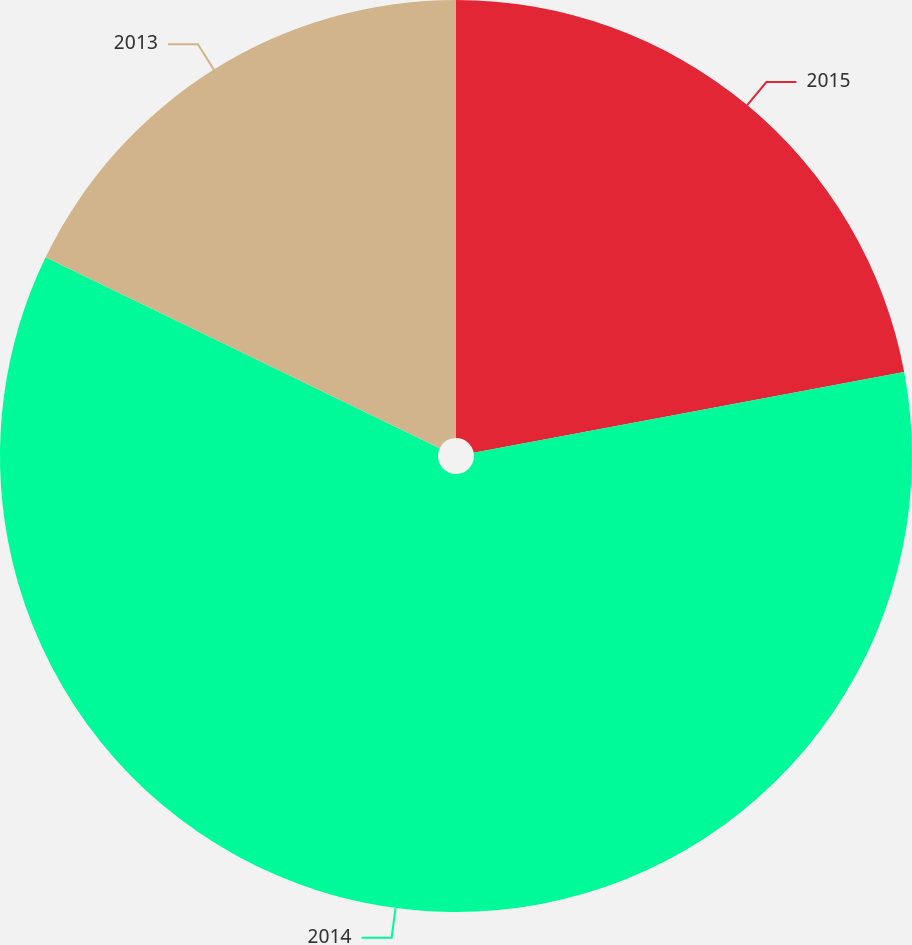Convert chart. <chart><loc_0><loc_0><loc_500><loc_500><pie_chart><fcel>2015<fcel>2014<fcel>2013<nl><fcel>22.05%<fcel>60.13%<fcel>17.82%<nl></chart> 